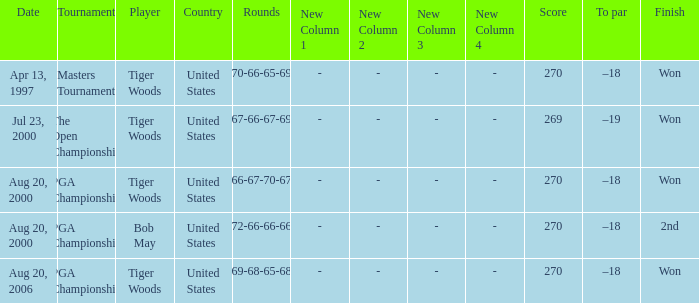What is the worst (highest) score? 270.0. 